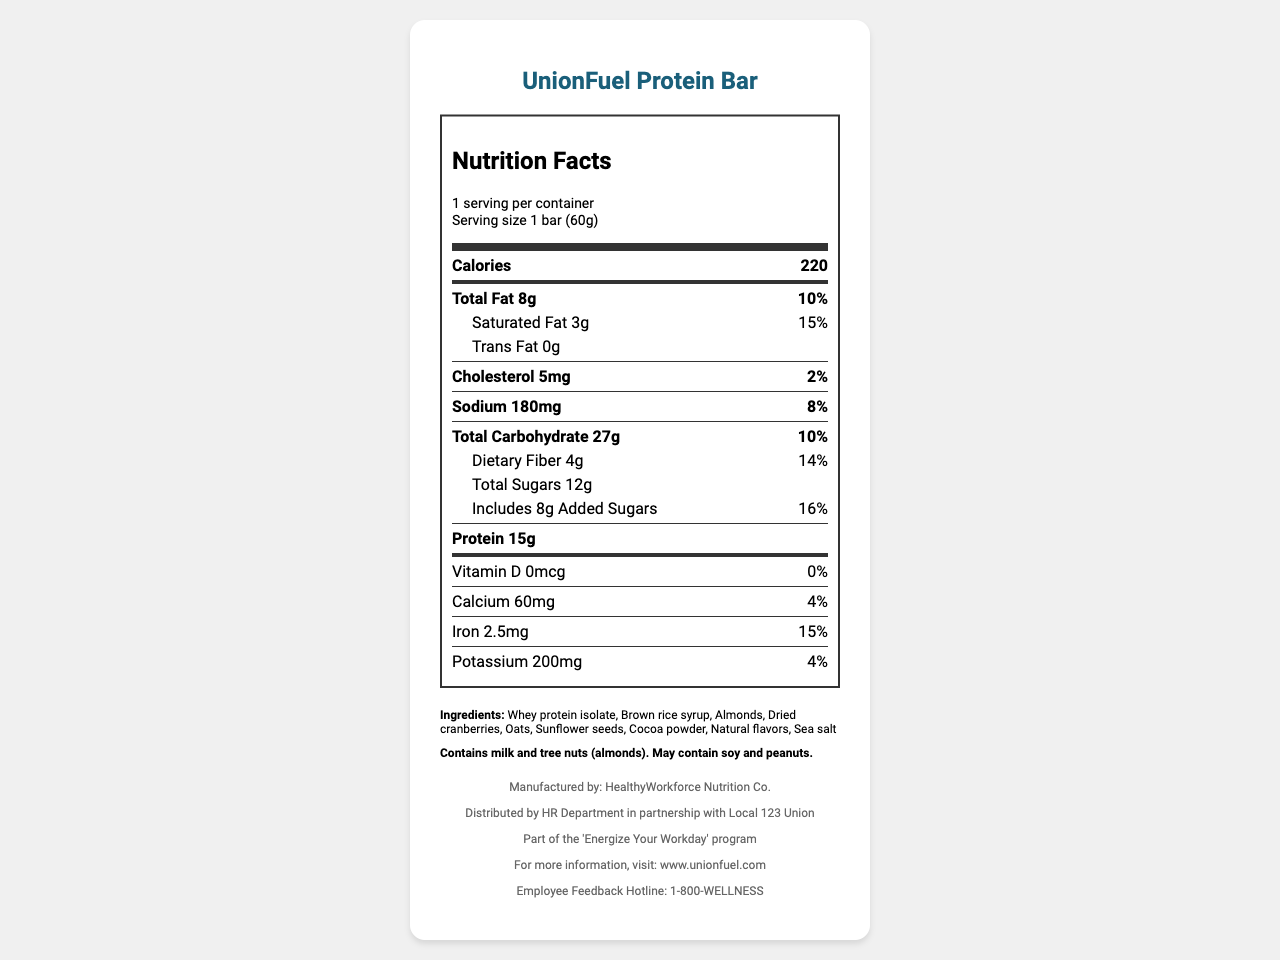what is the serving size of the UnionFuel Protein Bar? The serving size is clearly mentioned at the beginning of the nutrition label.
Answer: 1 bar (60g) how many grams of protein does the UnionFuel Protein Bar contain? The protein content is listed directly under the nutrition facts.
Answer: 15g what is the amount of total fat in the UnionFuel Protein Bar? The nutrition label lists total fat right after calories.
Answer: 8g how much dietary fiber does the UnionFuel Protein Bar have? The amount of dietary fiber is specified under total carbohydrate on the label.
Answer: 4g what is the daily value percentage of added sugars in the UnionFuel Protein Bar? The daily value percentage for added sugars is mentioned next to its amount under total sugars.
Answer: 16% how many calories are in one serving of the UnionFuel Protein Bar? The calorie content is prominently displayed near the top of the nutrition facts.
Answer: 220 how much calcium does the UnionFuel Protein Bar provide? The amount of calcium is listed towards the bottom of the nutrition facts.
Answer: 60mg what is the cholesterol content of the UnionFuel Protein Bar? A. 0mg B. 10mg C. 5mg D. 20mg The cholesterol content of the bar is 5mg as listed on the nutrition label.
Answer: C. 5mg which ingredient is NOT found in the UnionFuel Protein Bar? I. Whey protein isolate II. Brown rice syrup III. Coconut flakes Coconut flakes are not listed in the ingredients section of the UnionFuel Protein Bar.
Answer: III. Coconut flakes does the UnionFuel Protein Bar contain any trans fat? The label specifies that there are 0 grams of trans fat.
Answer: No summarize the nutrition highlights of the UnionFuel Protein Bar This summary captures the key nutritional information provided on the label, highlighting the main nutrients and their quantities.
Answer: The UnionFuel Protein Bar contains 220 calories per serving, 15g of protein, 8g of total fat, 27g of carbohydrates including 4g of dietary fiber, and 12g of total sugars, with 8g being added sugars. It also contains vitamins and minerals such as 60mg of calcium, 2.5mg of iron, and 200mg of potassium. what is the exact distribution date of the UnionFuel Protein Bar? The document does not provide any information regarding the exact distribution date of the UnionFuel Protein Bar.
Answer: Cannot be determined 